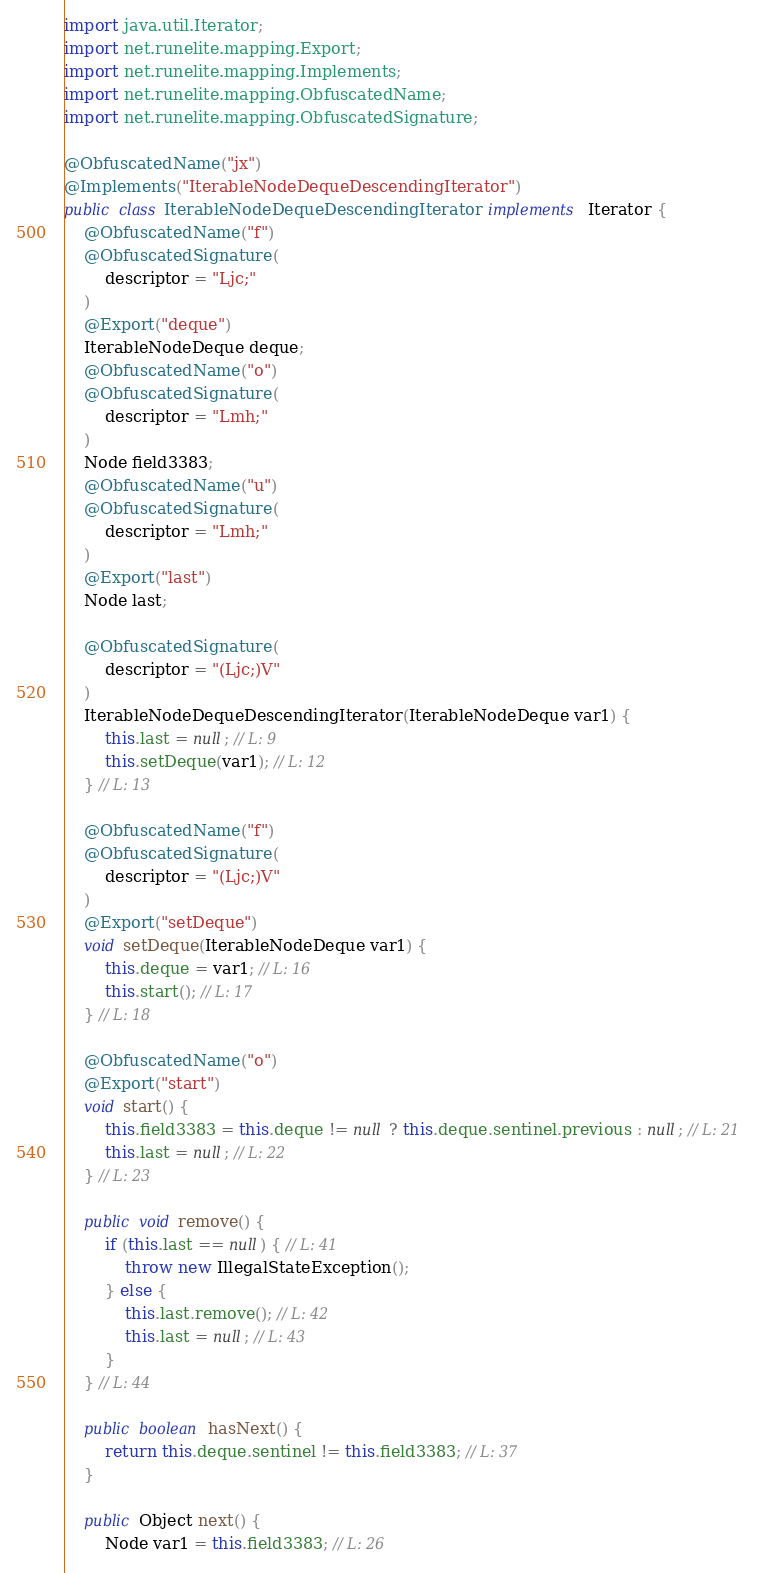<code> <loc_0><loc_0><loc_500><loc_500><_Java_>import java.util.Iterator;
import net.runelite.mapping.Export;
import net.runelite.mapping.Implements;
import net.runelite.mapping.ObfuscatedName;
import net.runelite.mapping.ObfuscatedSignature;

@ObfuscatedName("jx")
@Implements("IterableNodeDequeDescendingIterator")
public class IterableNodeDequeDescendingIterator implements Iterator {
	@ObfuscatedName("f")
	@ObfuscatedSignature(
		descriptor = "Ljc;"
	)
	@Export("deque")
	IterableNodeDeque deque;
	@ObfuscatedName("o")
	@ObfuscatedSignature(
		descriptor = "Lmh;"
	)
	Node field3383;
	@ObfuscatedName("u")
	@ObfuscatedSignature(
		descriptor = "Lmh;"
	)
	@Export("last")
	Node last;

	@ObfuscatedSignature(
		descriptor = "(Ljc;)V"
	)
	IterableNodeDequeDescendingIterator(IterableNodeDeque var1) {
		this.last = null; // L: 9
		this.setDeque(var1); // L: 12
	} // L: 13

	@ObfuscatedName("f")
	@ObfuscatedSignature(
		descriptor = "(Ljc;)V"
	)
	@Export("setDeque")
	void setDeque(IterableNodeDeque var1) {
		this.deque = var1; // L: 16
		this.start(); // L: 17
	} // L: 18

	@ObfuscatedName("o")
	@Export("start")
	void start() {
		this.field3383 = this.deque != null ? this.deque.sentinel.previous : null; // L: 21
		this.last = null; // L: 22
	} // L: 23

	public void remove() {
		if (this.last == null) { // L: 41
			throw new IllegalStateException();
		} else {
			this.last.remove(); // L: 42
			this.last = null; // L: 43
		}
	} // L: 44

	public boolean hasNext() {
		return this.deque.sentinel != this.field3383; // L: 37
	}

	public Object next() {
		Node var1 = this.field3383; // L: 26</code> 